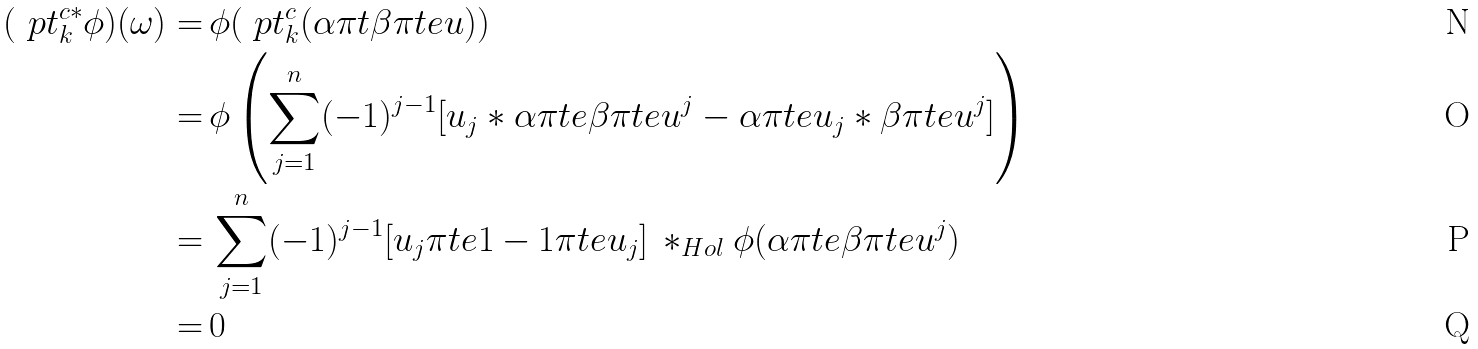Convert formula to latex. <formula><loc_0><loc_0><loc_500><loc_500>( \ p t _ { k } ^ { c * } \phi ) ( \omega ) = & \, \phi ( \ p t _ { k } ^ { c } ( \alpha \pi t \beta \pi t e u ) ) \\ = & \, \phi \left ( \sum _ { j = 1 } ^ { n } ( - 1 ) ^ { j - 1 } [ u _ { j } * \alpha \pi t e \beta \pi t e u ^ { j } - \alpha \pi t e u _ { j } * \beta \pi t e u ^ { j } ] \right ) \\ = & \, \sum _ { j = 1 } ^ { n } ( - 1 ) ^ { j - 1 } [ u _ { j } \pi t e 1 - 1 \pi t e u _ { j } ] \, * _ { H o l } \phi ( \alpha \pi t e \beta \pi t e u ^ { j } ) \\ = & \, 0</formula> 